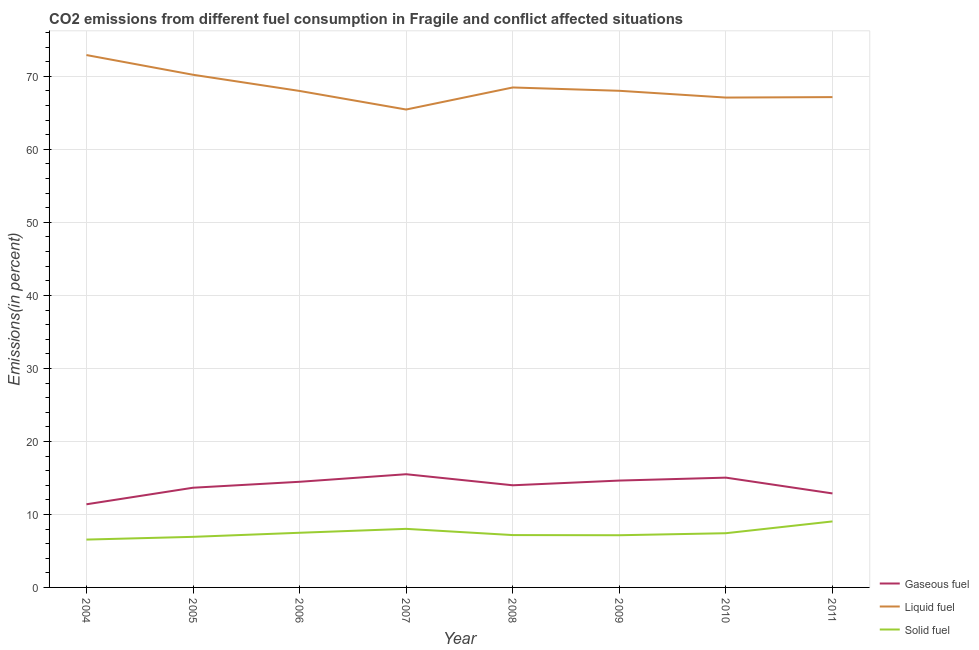How many different coloured lines are there?
Keep it short and to the point. 3. What is the percentage of gaseous fuel emission in 2010?
Give a very brief answer. 15.04. Across all years, what is the maximum percentage of gaseous fuel emission?
Offer a terse response. 15.51. Across all years, what is the minimum percentage of liquid fuel emission?
Your response must be concise. 65.46. In which year was the percentage of solid fuel emission maximum?
Your response must be concise. 2011. In which year was the percentage of solid fuel emission minimum?
Give a very brief answer. 2004. What is the total percentage of gaseous fuel emission in the graph?
Provide a succinct answer. 111.56. What is the difference between the percentage of gaseous fuel emission in 2006 and that in 2008?
Provide a succinct answer. 0.48. What is the difference between the percentage of solid fuel emission in 2010 and the percentage of gaseous fuel emission in 2007?
Offer a terse response. -8.08. What is the average percentage of gaseous fuel emission per year?
Your answer should be very brief. 13.95. In the year 2004, what is the difference between the percentage of gaseous fuel emission and percentage of liquid fuel emission?
Give a very brief answer. -61.53. In how many years, is the percentage of liquid fuel emission greater than 20 %?
Ensure brevity in your answer.  8. What is the ratio of the percentage of solid fuel emission in 2005 to that in 2010?
Offer a terse response. 0.93. What is the difference between the highest and the second highest percentage of solid fuel emission?
Your response must be concise. 1.02. What is the difference between the highest and the lowest percentage of liquid fuel emission?
Provide a short and direct response. 7.46. In how many years, is the percentage of solid fuel emission greater than the average percentage of solid fuel emission taken over all years?
Your answer should be compact. 3. Is the sum of the percentage of liquid fuel emission in 2007 and 2011 greater than the maximum percentage of gaseous fuel emission across all years?
Your answer should be very brief. Yes. Is it the case that in every year, the sum of the percentage of gaseous fuel emission and percentage of liquid fuel emission is greater than the percentage of solid fuel emission?
Offer a terse response. Yes. Is the percentage of solid fuel emission strictly greater than the percentage of liquid fuel emission over the years?
Your answer should be compact. No. Is the percentage of solid fuel emission strictly less than the percentage of liquid fuel emission over the years?
Give a very brief answer. Yes. How many lines are there?
Keep it short and to the point. 3. Where does the legend appear in the graph?
Offer a very short reply. Bottom right. What is the title of the graph?
Your response must be concise. CO2 emissions from different fuel consumption in Fragile and conflict affected situations. What is the label or title of the X-axis?
Keep it short and to the point. Year. What is the label or title of the Y-axis?
Give a very brief answer. Emissions(in percent). What is the Emissions(in percent) in Gaseous fuel in 2004?
Provide a short and direct response. 11.39. What is the Emissions(in percent) in Liquid fuel in 2004?
Offer a very short reply. 72.92. What is the Emissions(in percent) of Solid fuel in 2004?
Ensure brevity in your answer.  6.55. What is the Emissions(in percent) in Gaseous fuel in 2005?
Your answer should be very brief. 13.66. What is the Emissions(in percent) in Liquid fuel in 2005?
Your answer should be very brief. 70.22. What is the Emissions(in percent) of Solid fuel in 2005?
Give a very brief answer. 6.93. What is the Emissions(in percent) of Gaseous fuel in 2006?
Provide a short and direct response. 14.47. What is the Emissions(in percent) of Liquid fuel in 2006?
Your response must be concise. 68. What is the Emissions(in percent) in Solid fuel in 2006?
Your response must be concise. 7.49. What is the Emissions(in percent) of Gaseous fuel in 2007?
Provide a short and direct response. 15.51. What is the Emissions(in percent) in Liquid fuel in 2007?
Your answer should be compact. 65.46. What is the Emissions(in percent) of Solid fuel in 2007?
Your answer should be very brief. 8.02. What is the Emissions(in percent) in Gaseous fuel in 2008?
Your answer should be very brief. 13.99. What is the Emissions(in percent) of Liquid fuel in 2008?
Offer a very short reply. 68.48. What is the Emissions(in percent) of Solid fuel in 2008?
Provide a short and direct response. 7.17. What is the Emissions(in percent) of Gaseous fuel in 2009?
Give a very brief answer. 14.64. What is the Emissions(in percent) in Liquid fuel in 2009?
Give a very brief answer. 68.03. What is the Emissions(in percent) of Solid fuel in 2009?
Provide a succinct answer. 7.15. What is the Emissions(in percent) of Gaseous fuel in 2010?
Give a very brief answer. 15.04. What is the Emissions(in percent) of Liquid fuel in 2010?
Provide a succinct answer. 67.1. What is the Emissions(in percent) of Solid fuel in 2010?
Offer a terse response. 7.43. What is the Emissions(in percent) in Gaseous fuel in 2011?
Keep it short and to the point. 12.88. What is the Emissions(in percent) in Liquid fuel in 2011?
Keep it short and to the point. 67.16. What is the Emissions(in percent) of Solid fuel in 2011?
Offer a terse response. 9.04. Across all years, what is the maximum Emissions(in percent) in Gaseous fuel?
Your answer should be very brief. 15.51. Across all years, what is the maximum Emissions(in percent) of Liquid fuel?
Ensure brevity in your answer.  72.92. Across all years, what is the maximum Emissions(in percent) in Solid fuel?
Your answer should be compact. 9.04. Across all years, what is the minimum Emissions(in percent) of Gaseous fuel?
Your answer should be compact. 11.39. Across all years, what is the minimum Emissions(in percent) of Liquid fuel?
Keep it short and to the point. 65.46. Across all years, what is the minimum Emissions(in percent) in Solid fuel?
Your answer should be very brief. 6.55. What is the total Emissions(in percent) of Gaseous fuel in the graph?
Provide a succinct answer. 111.56. What is the total Emissions(in percent) of Liquid fuel in the graph?
Offer a very short reply. 547.38. What is the total Emissions(in percent) of Solid fuel in the graph?
Your response must be concise. 59.78. What is the difference between the Emissions(in percent) of Gaseous fuel in 2004 and that in 2005?
Provide a short and direct response. -2.27. What is the difference between the Emissions(in percent) of Liquid fuel in 2004 and that in 2005?
Give a very brief answer. 2.7. What is the difference between the Emissions(in percent) in Solid fuel in 2004 and that in 2005?
Keep it short and to the point. -0.38. What is the difference between the Emissions(in percent) of Gaseous fuel in 2004 and that in 2006?
Your answer should be very brief. -3.08. What is the difference between the Emissions(in percent) of Liquid fuel in 2004 and that in 2006?
Your response must be concise. 4.92. What is the difference between the Emissions(in percent) in Solid fuel in 2004 and that in 2006?
Ensure brevity in your answer.  -0.93. What is the difference between the Emissions(in percent) of Gaseous fuel in 2004 and that in 2007?
Give a very brief answer. -4.12. What is the difference between the Emissions(in percent) in Liquid fuel in 2004 and that in 2007?
Your response must be concise. 7.46. What is the difference between the Emissions(in percent) of Solid fuel in 2004 and that in 2007?
Provide a succinct answer. -1.47. What is the difference between the Emissions(in percent) in Gaseous fuel in 2004 and that in 2008?
Offer a terse response. -2.6. What is the difference between the Emissions(in percent) in Liquid fuel in 2004 and that in 2008?
Offer a very short reply. 4.44. What is the difference between the Emissions(in percent) in Solid fuel in 2004 and that in 2008?
Offer a very short reply. -0.62. What is the difference between the Emissions(in percent) of Gaseous fuel in 2004 and that in 2009?
Ensure brevity in your answer.  -3.25. What is the difference between the Emissions(in percent) in Liquid fuel in 2004 and that in 2009?
Provide a succinct answer. 4.9. What is the difference between the Emissions(in percent) of Solid fuel in 2004 and that in 2009?
Offer a very short reply. -0.6. What is the difference between the Emissions(in percent) of Gaseous fuel in 2004 and that in 2010?
Your answer should be compact. -3.65. What is the difference between the Emissions(in percent) of Liquid fuel in 2004 and that in 2010?
Offer a terse response. 5.82. What is the difference between the Emissions(in percent) of Solid fuel in 2004 and that in 2010?
Provide a short and direct response. -0.87. What is the difference between the Emissions(in percent) in Gaseous fuel in 2004 and that in 2011?
Keep it short and to the point. -1.49. What is the difference between the Emissions(in percent) in Liquid fuel in 2004 and that in 2011?
Your response must be concise. 5.76. What is the difference between the Emissions(in percent) of Solid fuel in 2004 and that in 2011?
Make the answer very short. -2.49. What is the difference between the Emissions(in percent) in Gaseous fuel in 2005 and that in 2006?
Offer a very short reply. -0.81. What is the difference between the Emissions(in percent) of Liquid fuel in 2005 and that in 2006?
Your answer should be compact. 2.22. What is the difference between the Emissions(in percent) in Solid fuel in 2005 and that in 2006?
Your answer should be compact. -0.56. What is the difference between the Emissions(in percent) in Gaseous fuel in 2005 and that in 2007?
Your answer should be very brief. -1.85. What is the difference between the Emissions(in percent) in Liquid fuel in 2005 and that in 2007?
Provide a short and direct response. 4.76. What is the difference between the Emissions(in percent) in Solid fuel in 2005 and that in 2007?
Provide a succinct answer. -1.09. What is the difference between the Emissions(in percent) of Gaseous fuel in 2005 and that in 2008?
Your response must be concise. -0.34. What is the difference between the Emissions(in percent) of Liquid fuel in 2005 and that in 2008?
Ensure brevity in your answer.  1.74. What is the difference between the Emissions(in percent) of Solid fuel in 2005 and that in 2008?
Give a very brief answer. -0.24. What is the difference between the Emissions(in percent) of Gaseous fuel in 2005 and that in 2009?
Give a very brief answer. -0.98. What is the difference between the Emissions(in percent) of Liquid fuel in 2005 and that in 2009?
Your response must be concise. 2.2. What is the difference between the Emissions(in percent) of Solid fuel in 2005 and that in 2009?
Your response must be concise. -0.22. What is the difference between the Emissions(in percent) of Gaseous fuel in 2005 and that in 2010?
Provide a short and direct response. -1.38. What is the difference between the Emissions(in percent) in Liquid fuel in 2005 and that in 2010?
Offer a terse response. 3.12. What is the difference between the Emissions(in percent) of Solid fuel in 2005 and that in 2010?
Your answer should be very brief. -0.5. What is the difference between the Emissions(in percent) of Gaseous fuel in 2005 and that in 2011?
Keep it short and to the point. 0.78. What is the difference between the Emissions(in percent) in Liquid fuel in 2005 and that in 2011?
Offer a very short reply. 3.06. What is the difference between the Emissions(in percent) in Solid fuel in 2005 and that in 2011?
Your response must be concise. -2.11. What is the difference between the Emissions(in percent) in Gaseous fuel in 2006 and that in 2007?
Offer a terse response. -1.04. What is the difference between the Emissions(in percent) in Liquid fuel in 2006 and that in 2007?
Your answer should be compact. 2.54. What is the difference between the Emissions(in percent) of Solid fuel in 2006 and that in 2007?
Your response must be concise. -0.54. What is the difference between the Emissions(in percent) in Gaseous fuel in 2006 and that in 2008?
Give a very brief answer. 0.48. What is the difference between the Emissions(in percent) in Liquid fuel in 2006 and that in 2008?
Ensure brevity in your answer.  -0.48. What is the difference between the Emissions(in percent) in Solid fuel in 2006 and that in 2008?
Provide a succinct answer. 0.32. What is the difference between the Emissions(in percent) of Gaseous fuel in 2006 and that in 2009?
Give a very brief answer. -0.17. What is the difference between the Emissions(in percent) of Liquid fuel in 2006 and that in 2009?
Make the answer very short. -0.02. What is the difference between the Emissions(in percent) in Solid fuel in 2006 and that in 2009?
Your answer should be compact. 0.34. What is the difference between the Emissions(in percent) of Gaseous fuel in 2006 and that in 2010?
Your answer should be very brief. -0.57. What is the difference between the Emissions(in percent) of Liquid fuel in 2006 and that in 2010?
Offer a terse response. 0.91. What is the difference between the Emissions(in percent) in Solid fuel in 2006 and that in 2010?
Offer a very short reply. 0.06. What is the difference between the Emissions(in percent) in Gaseous fuel in 2006 and that in 2011?
Your response must be concise. 1.59. What is the difference between the Emissions(in percent) of Liquid fuel in 2006 and that in 2011?
Your response must be concise. 0.84. What is the difference between the Emissions(in percent) of Solid fuel in 2006 and that in 2011?
Keep it short and to the point. -1.55. What is the difference between the Emissions(in percent) of Gaseous fuel in 2007 and that in 2008?
Offer a very short reply. 1.51. What is the difference between the Emissions(in percent) of Liquid fuel in 2007 and that in 2008?
Make the answer very short. -3.02. What is the difference between the Emissions(in percent) in Solid fuel in 2007 and that in 2008?
Your answer should be compact. 0.85. What is the difference between the Emissions(in percent) in Gaseous fuel in 2007 and that in 2009?
Your answer should be very brief. 0.87. What is the difference between the Emissions(in percent) of Liquid fuel in 2007 and that in 2009?
Your response must be concise. -2.57. What is the difference between the Emissions(in percent) in Solid fuel in 2007 and that in 2009?
Your response must be concise. 0.87. What is the difference between the Emissions(in percent) in Gaseous fuel in 2007 and that in 2010?
Your response must be concise. 0.47. What is the difference between the Emissions(in percent) of Liquid fuel in 2007 and that in 2010?
Keep it short and to the point. -1.64. What is the difference between the Emissions(in percent) in Solid fuel in 2007 and that in 2010?
Keep it short and to the point. 0.6. What is the difference between the Emissions(in percent) in Gaseous fuel in 2007 and that in 2011?
Give a very brief answer. 2.63. What is the difference between the Emissions(in percent) in Liquid fuel in 2007 and that in 2011?
Make the answer very short. -1.7. What is the difference between the Emissions(in percent) of Solid fuel in 2007 and that in 2011?
Ensure brevity in your answer.  -1.02. What is the difference between the Emissions(in percent) of Gaseous fuel in 2008 and that in 2009?
Your answer should be compact. -0.65. What is the difference between the Emissions(in percent) in Liquid fuel in 2008 and that in 2009?
Give a very brief answer. 0.45. What is the difference between the Emissions(in percent) in Solid fuel in 2008 and that in 2009?
Ensure brevity in your answer.  0.02. What is the difference between the Emissions(in percent) in Gaseous fuel in 2008 and that in 2010?
Provide a short and direct response. -1.05. What is the difference between the Emissions(in percent) of Liquid fuel in 2008 and that in 2010?
Give a very brief answer. 1.38. What is the difference between the Emissions(in percent) of Solid fuel in 2008 and that in 2010?
Keep it short and to the point. -0.26. What is the difference between the Emissions(in percent) in Gaseous fuel in 2008 and that in 2011?
Your answer should be compact. 1.12. What is the difference between the Emissions(in percent) in Liquid fuel in 2008 and that in 2011?
Your answer should be compact. 1.32. What is the difference between the Emissions(in percent) of Solid fuel in 2008 and that in 2011?
Your answer should be compact. -1.87. What is the difference between the Emissions(in percent) in Gaseous fuel in 2009 and that in 2010?
Provide a succinct answer. -0.4. What is the difference between the Emissions(in percent) of Liquid fuel in 2009 and that in 2010?
Provide a short and direct response. 0.93. What is the difference between the Emissions(in percent) in Solid fuel in 2009 and that in 2010?
Offer a terse response. -0.28. What is the difference between the Emissions(in percent) of Gaseous fuel in 2009 and that in 2011?
Your answer should be very brief. 1.76. What is the difference between the Emissions(in percent) in Liquid fuel in 2009 and that in 2011?
Your response must be concise. 0.87. What is the difference between the Emissions(in percent) of Solid fuel in 2009 and that in 2011?
Keep it short and to the point. -1.89. What is the difference between the Emissions(in percent) of Gaseous fuel in 2010 and that in 2011?
Keep it short and to the point. 2.16. What is the difference between the Emissions(in percent) of Liquid fuel in 2010 and that in 2011?
Your answer should be very brief. -0.06. What is the difference between the Emissions(in percent) in Solid fuel in 2010 and that in 2011?
Offer a terse response. -1.62. What is the difference between the Emissions(in percent) of Gaseous fuel in 2004 and the Emissions(in percent) of Liquid fuel in 2005?
Offer a terse response. -58.84. What is the difference between the Emissions(in percent) of Gaseous fuel in 2004 and the Emissions(in percent) of Solid fuel in 2005?
Provide a succinct answer. 4.46. What is the difference between the Emissions(in percent) in Liquid fuel in 2004 and the Emissions(in percent) in Solid fuel in 2005?
Offer a very short reply. 65.99. What is the difference between the Emissions(in percent) in Gaseous fuel in 2004 and the Emissions(in percent) in Liquid fuel in 2006?
Your response must be concise. -56.62. What is the difference between the Emissions(in percent) in Gaseous fuel in 2004 and the Emissions(in percent) in Solid fuel in 2006?
Ensure brevity in your answer.  3.9. What is the difference between the Emissions(in percent) in Liquid fuel in 2004 and the Emissions(in percent) in Solid fuel in 2006?
Your answer should be compact. 65.44. What is the difference between the Emissions(in percent) in Gaseous fuel in 2004 and the Emissions(in percent) in Liquid fuel in 2007?
Ensure brevity in your answer.  -54.07. What is the difference between the Emissions(in percent) in Gaseous fuel in 2004 and the Emissions(in percent) in Solid fuel in 2007?
Your answer should be compact. 3.37. What is the difference between the Emissions(in percent) in Liquid fuel in 2004 and the Emissions(in percent) in Solid fuel in 2007?
Keep it short and to the point. 64.9. What is the difference between the Emissions(in percent) in Gaseous fuel in 2004 and the Emissions(in percent) in Liquid fuel in 2008?
Give a very brief answer. -57.09. What is the difference between the Emissions(in percent) of Gaseous fuel in 2004 and the Emissions(in percent) of Solid fuel in 2008?
Make the answer very short. 4.22. What is the difference between the Emissions(in percent) of Liquid fuel in 2004 and the Emissions(in percent) of Solid fuel in 2008?
Your answer should be compact. 65.75. What is the difference between the Emissions(in percent) in Gaseous fuel in 2004 and the Emissions(in percent) in Liquid fuel in 2009?
Give a very brief answer. -56.64. What is the difference between the Emissions(in percent) of Gaseous fuel in 2004 and the Emissions(in percent) of Solid fuel in 2009?
Keep it short and to the point. 4.24. What is the difference between the Emissions(in percent) of Liquid fuel in 2004 and the Emissions(in percent) of Solid fuel in 2009?
Provide a short and direct response. 65.77. What is the difference between the Emissions(in percent) of Gaseous fuel in 2004 and the Emissions(in percent) of Liquid fuel in 2010?
Your answer should be very brief. -55.71. What is the difference between the Emissions(in percent) of Gaseous fuel in 2004 and the Emissions(in percent) of Solid fuel in 2010?
Offer a terse response. 3.96. What is the difference between the Emissions(in percent) of Liquid fuel in 2004 and the Emissions(in percent) of Solid fuel in 2010?
Your response must be concise. 65.5. What is the difference between the Emissions(in percent) in Gaseous fuel in 2004 and the Emissions(in percent) in Liquid fuel in 2011?
Ensure brevity in your answer.  -55.77. What is the difference between the Emissions(in percent) in Gaseous fuel in 2004 and the Emissions(in percent) in Solid fuel in 2011?
Keep it short and to the point. 2.35. What is the difference between the Emissions(in percent) of Liquid fuel in 2004 and the Emissions(in percent) of Solid fuel in 2011?
Keep it short and to the point. 63.88. What is the difference between the Emissions(in percent) in Gaseous fuel in 2005 and the Emissions(in percent) in Liquid fuel in 2006?
Offer a very short reply. -54.35. What is the difference between the Emissions(in percent) of Gaseous fuel in 2005 and the Emissions(in percent) of Solid fuel in 2006?
Ensure brevity in your answer.  6.17. What is the difference between the Emissions(in percent) of Liquid fuel in 2005 and the Emissions(in percent) of Solid fuel in 2006?
Give a very brief answer. 62.74. What is the difference between the Emissions(in percent) of Gaseous fuel in 2005 and the Emissions(in percent) of Liquid fuel in 2007?
Ensure brevity in your answer.  -51.8. What is the difference between the Emissions(in percent) in Gaseous fuel in 2005 and the Emissions(in percent) in Solid fuel in 2007?
Provide a succinct answer. 5.63. What is the difference between the Emissions(in percent) in Liquid fuel in 2005 and the Emissions(in percent) in Solid fuel in 2007?
Keep it short and to the point. 62.2. What is the difference between the Emissions(in percent) in Gaseous fuel in 2005 and the Emissions(in percent) in Liquid fuel in 2008?
Offer a terse response. -54.83. What is the difference between the Emissions(in percent) of Gaseous fuel in 2005 and the Emissions(in percent) of Solid fuel in 2008?
Ensure brevity in your answer.  6.49. What is the difference between the Emissions(in percent) of Liquid fuel in 2005 and the Emissions(in percent) of Solid fuel in 2008?
Offer a very short reply. 63.05. What is the difference between the Emissions(in percent) of Gaseous fuel in 2005 and the Emissions(in percent) of Liquid fuel in 2009?
Give a very brief answer. -54.37. What is the difference between the Emissions(in percent) in Gaseous fuel in 2005 and the Emissions(in percent) in Solid fuel in 2009?
Keep it short and to the point. 6.51. What is the difference between the Emissions(in percent) of Liquid fuel in 2005 and the Emissions(in percent) of Solid fuel in 2009?
Your answer should be very brief. 63.07. What is the difference between the Emissions(in percent) in Gaseous fuel in 2005 and the Emissions(in percent) in Liquid fuel in 2010?
Your answer should be compact. -53.44. What is the difference between the Emissions(in percent) of Gaseous fuel in 2005 and the Emissions(in percent) of Solid fuel in 2010?
Offer a very short reply. 6.23. What is the difference between the Emissions(in percent) of Liquid fuel in 2005 and the Emissions(in percent) of Solid fuel in 2010?
Ensure brevity in your answer.  62.8. What is the difference between the Emissions(in percent) of Gaseous fuel in 2005 and the Emissions(in percent) of Liquid fuel in 2011?
Provide a short and direct response. -53.5. What is the difference between the Emissions(in percent) of Gaseous fuel in 2005 and the Emissions(in percent) of Solid fuel in 2011?
Your answer should be very brief. 4.62. What is the difference between the Emissions(in percent) of Liquid fuel in 2005 and the Emissions(in percent) of Solid fuel in 2011?
Your answer should be very brief. 61.18. What is the difference between the Emissions(in percent) of Gaseous fuel in 2006 and the Emissions(in percent) of Liquid fuel in 2007?
Keep it short and to the point. -50.99. What is the difference between the Emissions(in percent) in Gaseous fuel in 2006 and the Emissions(in percent) in Solid fuel in 2007?
Your response must be concise. 6.45. What is the difference between the Emissions(in percent) of Liquid fuel in 2006 and the Emissions(in percent) of Solid fuel in 2007?
Offer a terse response. 59.98. What is the difference between the Emissions(in percent) in Gaseous fuel in 2006 and the Emissions(in percent) in Liquid fuel in 2008?
Your response must be concise. -54.01. What is the difference between the Emissions(in percent) in Gaseous fuel in 2006 and the Emissions(in percent) in Solid fuel in 2008?
Make the answer very short. 7.3. What is the difference between the Emissions(in percent) in Liquid fuel in 2006 and the Emissions(in percent) in Solid fuel in 2008?
Keep it short and to the point. 60.83. What is the difference between the Emissions(in percent) in Gaseous fuel in 2006 and the Emissions(in percent) in Liquid fuel in 2009?
Give a very brief answer. -53.56. What is the difference between the Emissions(in percent) of Gaseous fuel in 2006 and the Emissions(in percent) of Solid fuel in 2009?
Offer a terse response. 7.32. What is the difference between the Emissions(in percent) in Liquid fuel in 2006 and the Emissions(in percent) in Solid fuel in 2009?
Make the answer very short. 60.86. What is the difference between the Emissions(in percent) of Gaseous fuel in 2006 and the Emissions(in percent) of Liquid fuel in 2010?
Your answer should be very brief. -52.63. What is the difference between the Emissions(in percent) in Gaseous fuel in 2006 and the Emissions(in percent) in Solid fuel in 2010?
Keep it short and to the point. 7.04. What is the difference between the Emissions(in percent) in Liquid fuel in 2006 and the Emissions(in percent) in Solid fuel in 2010?
Provide a succinct answer. 60.58. What is the difference between the Emissions(in percent) of Gaseous fuel in 2006 and the Emissions(in percent) of Liquid fuel in 2011?
Your response must be concise. -52.69. What is the difference between the Emissions(in percent) of Gaseous fuel in 2006 and the Emissions(in percent) of Solid fuel in 2011?
Ensure brevity in your answer.  5.43. What is the difference between the Emissions(in percent) of Liquid fuel in 2006 and the Emissions(in percent) of Solid fuel in 2011?
Ensure brevity in your answer.  58.96. What is the difference between the Emissions(in percent) of Gaseous fuel in 2007 and the Emissions(in percent) of Liquid fuel in 2008?
Offer a terse response. -52.98. What is the difference between the Emissions(in percent) of Gaseous fuel in 2007 and the Emissions(in percent) of Solid fuel in 2008?
Ensure brevity in your answer.  8.34. What is the difference between the Emissions(in percent) of Liquid fuel in 2007 and the Emissions(in percent) of Solid fuel in 2008?
Make the answer very short. 58.29. What is the difference between the Emissions(in percent) of Gaseous fuel in 2007 and the Emissions(in percent) of Liquid fuel in 2009?
Make the answer very short. -52.52. What is the difference between the Emissions(in percent) in Gaseous fuel in 2007 and the Emissions(in percent) in Solid fuel in 2009?
Your answer should be compact. 8.36. What is the difference between the Emissions(in percent) of Liquid fuel in 2007 and the Emissions(in percent) of Solid fuel in 2009?
Provide a succinct answer. 58.31. What is the difference between the Emissions(in percent) in Gaseous fuel in 2007 and the Emissions(in percent) in Liquid fuel in 2010?
Offer a very short reply. -51.59. What is the difference between the Emissions(in percent) of Gaseous fuel in 2007 and the Emissions(in percent) of Solid fuel in 2010?
Offer a terse response. 8.08. What is the difference between the Emissions(in percent) of Liquid fuel in 2007 and the Emissions(in percent) of Solid fuel in 2010?
Provide a succinct answer. 58.04. What is the difference between the Emissions(in percent) of Gaseous fuel in 2007 and the Emissions(in percent) of Liquid fuel in 2011?
Offer a very short reply. -51.65. What is the difference between the Emissions(in percent) in Gaseous fuel in 2007 and the Emissions(in percent) in Solid fuel in 2011?
Provide a short and direct response. 6.46. What is the difference between the Emissions(in percent) of Liquid fuel in 2007 and the Emissions(in percent) of Solid fuel in 2011?
Ensure brevity in your answer.  56.42. What is the difference between the Emissions(in percent) in Gaseous fuel in 2008 and the Emissions(in percent) in Liquid fuel in 2009?
Your response must be concise. -54.04. What is the difference between the Emissions(in percent) of Gaseous fuel in 2008 and the Emissions(in percent) of Solid fuel in 2009?
Your answer should be compact. 6.84. What is the difference between the Emissions(in percent) in Liquid fuel in 2008 and the Emissions(in percent) in Solid fuel in 2009?
Offer a very short reply. 61.33. What is the difference between the Emissions(in percent) in Gaseous fuel in 2008 and the Emissions(in percent) in Liquid fuel in 2010?
Make the answer very short. -53.11. What is the difference between the Emissions(in percent) in Gaseous fuel in 2008 and the Emissions(in percent) in Solid fuel in 2010?
Offer a terse response. 6.57. What is the difference between the Emissions(in percent) of Liquid fuel in 2008 and the Emissions(in percent) of Solid fuel in 2010?
Keep it short and to the point. 61.06. What is the difference between the Emissions(in percent) of Gaseous fuel in 2008 and the Emissions(in percent) of Liquid fuel in 2011?
Give a very brief answer. -53.17. What is the difference between the Emissions(in percent) of Gaseous fuel in 2008 and the Emissions(in percent) of Solid fuel in 2011?
Provide a short and direct response. 4.95. What is the difference between the Emissions(in percent) in Liquid fuel in 2008 and the Emissions(in percent) in Solid fuel in 2011?
Your response must be concise. 59.44. What is the difference between the Emissions(in percent) in Gaseous fuel in 2009 and the Emissions(in percent) in Liquid fuel in 2010?
Offer a terse response. -52.46. What is the difference between the Emissions(in percent) of Gaseous fuel in 2009 and the Emissions(in percent) of Solid fuel in 2010?
Provide a short and direct response. 7.21. What is the difference between the Emissions(in percent) in Liquid fuel in 2009 and the Emissions(in percent) in Solid fuel in 2010?
Offer a terse response. 60.6. What is the difference between the Emissions(in percent) of Gaseous fuel in 2009 and the Emissions(in percent) of Liquid fuel in 2011?
Your answer should be very brief. -52.52. What is the difference between the Emissions(in percent) of Gaseous fuel in 2009 and the Emissions(in percent) of Solid fuel in 2011?
Offer a very short reply. 5.6. What is the difference between the Emissions(in percent) of Liquid fuel in 2009 and the Emissions(in percent) of Solid fuel in 2011?
Your response must be concise. 58.99. What is the difference between the Emissions(in percent) in Gaseous fuel in 2010 and the Emissions(in percent) in Liquid fuel in 2011?
Keep it short and to the point. -52.12. What is the difference between the Emissions(in percent) of Gaseous fuel in 2010 and the Emissions(in percent) of Solid fuel in 2011?
Give a very brief answer. 6. What is the difference between the Emissions(in percent) in Liquid fuel in 2010 and the Emissions(in percent) in Solid fuel in 2011?
Keep it short and to the point. 58.06. What is the average Emissions(in percent) of Gaseous fuel per year?
Provide a short and direct response. 13.95. What is the average Emissions(in percent) in Liquid fuel per year?
Offer a very short reply. 68.42. What is the average Emissions(in percent) in Solid fuel per year?
Offer a terse response. 7.47. In the year 2004, what is the difference between the Emissions(in percent) of Gaseous fuel and Emissions(in percent) of Liquid fuel?
Provide a short and direct response. -61.53. In the year 2004, what is the difference between the Emissions(in percent) of Gaseous fuel and Emissions(in percent) of Solid fuel?
Your answer should be very brief. 4.83. In the year 2004, what is the difference between the Emissions(in percent) of Liquid fuel and Emissions(in percent) of Solid fuel?
Give a very brief answer. 66.37. In the year 2005, what is the difference between the Emissions(in percent) of Gaseous fuel and Emissions(in percent) of Liquid fuel?
Provide a short and direct response. -56.57. In the year 2005, what is the difference between the Emissions(in percent) in Gaseous fuel and Emissions(in percent) in Solid fuel?
Offer a terse response. 6.73. In the year 2005, what is the difference between the Emissions(in percent) in Liquid fuel and Emissions(in percent) in Solid fuel?
Your response must be concise. 63.29. In the year 2006, what is the difference between the Emissions(in percent) of Gaseous fuel and Emissions(in percent) of Liquid fuel?
Provide a succinct answer. -53.53. In the year 2006, what is the difference between the Emissions(in percent) in Gaseous fuel and Emissions(in percent) in Solid fuel?
Your answer should be compact. 6.98. In the year 2006, what is the difference between the Emissions(in percent) in Liquid fuel and Emissions(in percent) in Solid fuel?
Offer a very short reply. 60.52. In the year 2007, what is the difference between the Emissions(in percent) of Gaseous fuel and Emissions(in percent) of Liquid fuel?
Offer a terse response. -49.96. In the year 2007, what is the difference between the Emissions(in percent) of Gaseous fuel and Emissions(in percent) of Solid fuel?
Provide a succinct answer. 7.48. In the year 2007, what is the difference between the Emissions(in percent) in Liquid fuel and Emissions(in percent) in Solid fuel?
Keep it short and to the point. 57.44. In the year 2008, what is the difference between the Emissions(in percent) in Gaseous fuel and Emissions(in percent) in Liquid fuel?
Offer a terse response. -54.49. In the year 2008, what is the difference between the Emissions(in percent) in Gaseous fuel and Emissions(in percent) in Solid fuel?
Provide a succinct answer. 6.82. In the year 2008, what is the difference between the Emissions(in percent) in Liquid fuel and Emissions(in percent) in Solid fuel?
Give a very brief answer. 61.31. In the year 2009, what is the difference between the Emissions(in percent) in Gaseous fuel and Emissions(in percent) in Liquid fuel?
Provide a succinct answer. -53.39. In the year 2009, what is the difference between the Emissions(in percent) in Gaseous fuel and Emissions(in percent) in Solid fuel?
Make the answer very short. 7.49. In the year 2009, what is the difference between the Emissions(in percent) in Liquid fuel and Emissions(in percent) in Solid fuel?
Your answer should be compact. 60.88. In the year 2010, what is the difference between the Emissions(in percent) in Gaseous fuel and Emissions(in percent) in Liquid fuel?
Your response must be concise. -52.06. In the year 2010, what is the difference between the Emissions(in percent) of Gaseous fuel and Emissions(in percent) of Solid fuel?
Provide a short and direct response. 7.61. In the year 2010, what is the difference between the Emissions(in percent) of Liquid fuel and Emissions(in percent) of Solid fuel?
Make the answer very short. 59.67. In the year 2011, what is the difference between the Emissions(in percent) of Gaseous fuel and Emissions(in percent) of Liquid fuel?
Offer a terse response. -54.29. In the year 2011, what is the difference between the Emissions(in percent) of Gaseous fuel and Emissions(in percent) of Solid fuel?
Your response must be concise. 3.83. In the year 2011, what is the difference between the Emissions(in percent) in Liquid fuel and Emissions(in percent) in Solid fuel?
Give a very brief answer. 58.12. What is the ratio of the Emissions(in percent) of Gaseous fuel in 2004 to that in 2005?
Ensure brevity in your answer.  0.83. What is the ratio of the Emissions(in percent) of Liquid fuel in 2004 to that in 2005?
Keep it short and to the point. 1.04. What is the ratio of the Emissions(in percent) in Solid fuel in 2004 to that in 2005?
Make the answer very short. 0.95. What is the ratio of the Emissions(in percent) in Gaseous fuel in 2004 to that in 2006?
Provide a short and direct response. 0.79. What is the ratio of the Emissions(in percent) in Liquid fuel in 2004 to that in 2006?
Make the answer very short. 1.07. What is the ratio of the Emissions(in percent) in Solid fuel in 2004 to that in 2006?
Make the answer very short. 0.88. What is the ratio of the Emissions(in percent) in Gaseous fuel in 2004 to that in 2007?
Keep it short and to the point. 0.73. What is the ratio of the Emissions(in percent) of Liquid fuel in 2004 to that in 2007?
Your response must be concise. 1.11. What is the ratio of the Emissions(in percent) in Solid fuel in 2004 to that in 2007?
Provide a succinct answer. 0.82. What is the ratio of the Emissions(in percent) in Gaseous fuel in 2004 to that in 2008?
Give a very brief answer. 0.81. What is the ratio of the Emissions(in percent) in Liquid fuel in 2004 to that in 2008?
Provide a short and direct response. 1.06. What is the ratio of the Emissions(in percent) in Solid fuel in 2004 to that in 2008?
Your response must be concise. 0.91. What is the ratio of the Emissions(in percent) of Gaseous fuel in 2004 to that in 2009?
Make the answer very short. 0.78. What is the ratio of the Emissions(in percent) of Liquid fuel in 2004 to that in 2009?
Offer a very short reply. 1.07. What is the ratio of the Emissions(in percent) in Solid fuel in 2004 to that in 2009?
Your response must be concise. 0.92. What is the ratio of the Emissions(in percent) in Gaseous fuel in 2004 to that in 2010?
Offer a terse response. 0.76. What is the ratio of the Emissions(in percent) of Liquid fuel in 2004 to that in 2010?
Provide a short and direct response. 1.09. What is the ratio of the Emissions(in percent) in Solid fuel in 2004 to that in 2010?
Give a very brief answer. 0.88. What is the ratio of the Emissions(in percent) in Gaseous fuel in 2004 to that in 2011?
Provide a short and direct response. 0.88. What is the ratio of the Emissions(in percent) in Liquid fuel in 2004 to that in 2011?
Your response must be concise. 1.09. What is the ratio of the Emissions(in percent) in Solid fuel in 2004 to that in 2011?
Provide a succinct answer. 0.72. What is the ratio of the Emissions(in percent) of Gaseous fuel in 2005 to that in 2006?
Offer a terse response. 0.94. What is the ratio of the Emissions(in percent) of Liquid fuel in 2005 to that in 2006?
Offer a very short reply. 1.03. What is the ratio of the Emissions(in percent) of Solid fuel in 2005 to that in 2006?
Ensure brevity in your answer.  0.93. What is the ratio of the Emissions(in percent) in Gaseous fuel in 2005 to that in 2007?
Give a very brief answer. 0.88. What is the ratio of the Emissions(in percent) of Liquid fuel in 2005 to that in 2007?
Make the answer very short. 1.07. What is the ratio of the Emissions(in percent) in Solid fuel in 2005 to that in 2007?
Give a very brief answer. 0.86. What is the ratio of the Emissions(in percent) of Gaseous fuel in 2005 to that in 2008?
Provide a succinct answer. 0.98. What is the ratio of the Emissions(in percent) of Liquid fuel in 2005 to that in 2008?
Your response must be concise. 1.03. What is the ratio of the Emissions(in percent) of Solid fuel in 2005 to that in 2008?
Your answer should be very brief. 0.97. What is the ratio of the Emissions(in percent) of Gaseous fuel in 2005 to that in 2009?
Ensure brevity in your answer.  0.93. What is the ratio of the Emissions(in percent) in Liquid fuel in 2005 to that in 2009?
Ensure brevity in your answer.  1.03. What is the ratio of the Emissions(in percent) in Solid fuel in 2005 to that in 2009?
Your answer should be compact. 0.97. What is the ratio of the Emissions(in percent) in Gaseous fuel in 2005 to that in 2010?
Provide a short and direct response. 0.91. What is the ratio of the Emissions(in percent) of Liquid fuel in 2005 to that in 2010?
Give a very brief answer. 1.05. What is the ratio of the Emissions(in percent) in Solid fuel in 2005 to that in 2010?
Your response must be concise. 0.93. What is the ratio of the Emissions(in percent) of Gaseous fuel in 2005 to that in 2011?
Make the answer very short. 1.06. What is the ratio of the Emissions(in percent) in Liquid fuel in 2005 to that in 2011?
Your answer should be very brief. 1.05. What is the ratio of the Emissions(in percent) in Solid fuel in 2005 to that in 2011?
Keep it short and to the point. 0.77. What is the ratio of the Emissions(in percent) in Gaseous fuel in 2006 to that in 2007?
Provide a succinct answer. 0.93. What is the ratio of the Emissions(in percent) in Liquid fuel in 2006 to that in 2007?
Offer a very short reply. 1.04. What is the ratio of the Emissions(in percent) of Solid fuel in 2006 to that in 2007?
Your response must be concise. 0.93. What is the ratio of the Emissions(in percent) of Gaseous fuel in 2006 to that in 2008?
Provide a succinct answer. 1.03. What is the ratio of the Emissions(in percent) in Solid fuel in 2006 to that in 2008?
Provide a short and direct response. 1.04. What is the ratio of the Emissions(in percent) in Solid fuel in 2006 to that in 2009?
Your answer should be very brief. 1.05. What is the ratio of the Emissions(in percent) in Gaseous fuel in 2006 to that in 2010?
Your answer should be very brief. 0.96. What is the ratio of the Emissions(in percent) in Liquid fuel in 2006 to that in 2010?
Make the answer very short. 1.01. What is the ratio of the Emissions(in percent) in Solid fuel in 2006 to that in 2010?
Make the answer very short. 1.01. What is the ratio of the Emissions(in percent) of Gaseous fuel in 2006 to that in 2011?
Ensure brevity in your answer.  1.12. What is the ratio of the Emissions(in percent) in Liquid fuel in 2006 to that in 2011?
Ensure brevity in your answer.  1.01. What is the ratio of the Emissions(in percent) in Solid fuel in 2006 to that in 2011?
Give a very brief answer. 0.83. What is the ratio of the Emissions(in percent) in Gaseous fuel in 2007 to that in 2008?
Provide a succinct answer. 1.11. What is the ratio of the Emissions(in percent) in Liquid fuel in 2007 to that in 2008?
Provide a short and direct response. 0.96. What is the ratio of the Emissions(in percent) of Solid fuel in 2007 to that in 2008?
Give a very brief answer. 1.12. What is the ratio of the Emissions(in percent) of Gaseous fuel in 2007 to that in 2009?
Your answer should be compact. 1.06. What is the ratio of the Emissions(in percent) of Liquid fuel in 2007 to that in 2009?
Give a very brief answer. 0.96. What is the ratio of the Emissions(in percent) in Solid fuel in 2007 to that in 2009?
Provide a succinct answer. 1.12. What is the ratio of the Emissions(in percent) of Gaseous fuel in 2007 to that in 2010?
Ensure brevity in your answer.  1.03. What is the ratio of the Emissions(in percent) in Liquid fuel in 2007 to that in 2010?
Your response must be concise. 0.98. What is the ratio of the Emissions(in percent) of Solid fuel in 2007 to that in 2010?
Offer a terse response. 1.08. What is the ratio of the Emissions(in percent) of Gaseous fuel in 2007 to that in 2011?
Offer a very short reply. 1.2. What is the ratio of the Emissions(in percent) in Liquid fuel in 2007 to that in 2011?
Offer a very short reply. 0.97. What is the ratio of the Emissions(in percent) in Solid fuel in 2007 to that in 2011?
Ensure brevity in your answer.  0.89. What is the ratio of the Emissions(in percent) in Gaseous fuel in 2008 to that in 2009?
Keep it short and to the point. 0.96. What is the ratio of the Emissions(in percent) of Gaseous fuel in 2008 to that in 2010?
Your response must be concise. 0.93. What is the ratio of the Emissions(in percent) in Liquid fuel in 2008 to that in 2010?
Ensure brevity in your answer.  1.02. What is the ratio of the Emissions(in percent) in Solid fuel in 2008 to that in 2010?
Your answer should be compact. 0.97. What is the ratio of the Emissions(in percent) in Gaseous fuel in 2008 to that in 2011?
Make the answer very short. 1.09. What is the ratio of the Emissions(in percent) of Liquid fuel in 2008 to that in 2011?
Offer a terse response. 1.02. What is the ratio of the Emissions(in percent) in Solid fuel in 2008 to that in 2011?
Provide a short and direct response. 0.79. What is the ratio of the Emissions(in percent) of Gaseous fuel in 2009 to that in 2010?
Provide a succinct answer. 0.97. What is the ratio of the Emissions(in percent) of Liquid fuel in 2009 to that in 2010?
Your answer should be very brief. 1.01. What is the ratio of the Emissions(in percent) of Solid fuel in 2009 to that in 2010?
Give a very brief answer. 0.96. What is the ratio of the Emissions(in percent) of Gaseous fuel in 2009 to that in 2011?
Make the answer very short. 1.14. What is the ratio of the Emissions(in percent) in Liquid fuel in 2009 to that in 2011?
Give a very brief answer. 1.01. What is the ratio of the Emissions(in percent) of Solid fuel in 2009 to that in 2011?
Make the answer very short. 0.79. What is the ratio of the Emissions(in percent) in Gaseous fuel in 2010 to that in 2011?
Your answer should be very brief. 1.17. What is the ratio of the Emissions(in percent) in Solid fuel in 2010 to that in 2011?
Make the answer very short. 0.82. What is the difference between the highest and the second highest Emissions(in percent) in Gaseous fuel?
Make the answer very short. 0.47. What is the difference between the highest and the second highest Emissions(in percent) of Liquid fuel?
Make the answer very short. 2.7. What is the difference between the highest and the second highest Emissions(in percent) of Solid fuel?
Make the answer very short. 1.02. What is the difference between the highest and the lowest Emissions(in percent) of Gaseous fuel?
Your response must be concise. 4.12. What is the difference between the highest and the lowest Emissions(in percent) in Liquid fuel?
Your response must be concise. 7.46. What is the difference between the highest and the lowest Emissions(in percent) of Solid fuel?
Provide a short and direct response. 2.49. 